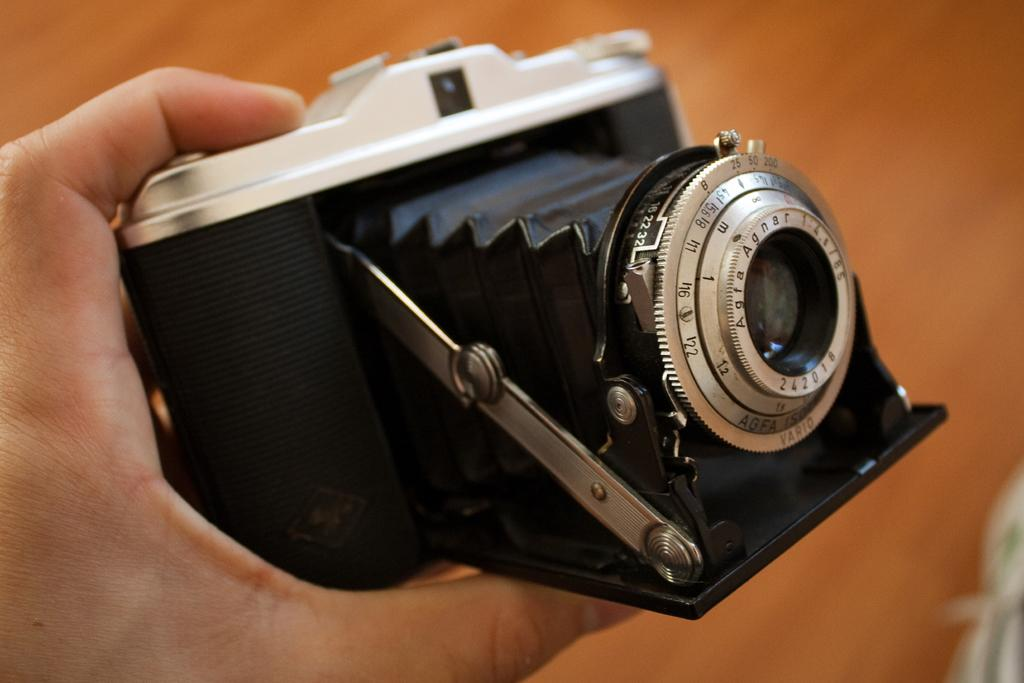What is the main subject of the image? There is a person in the image. What is the person holding in the image? The person is holding a camera. What can be said about the color of the camera? The camera is black in color. How many kittens can be seen playing on the earth in the image? There are no kittens or any reference to the earth present in the image. 